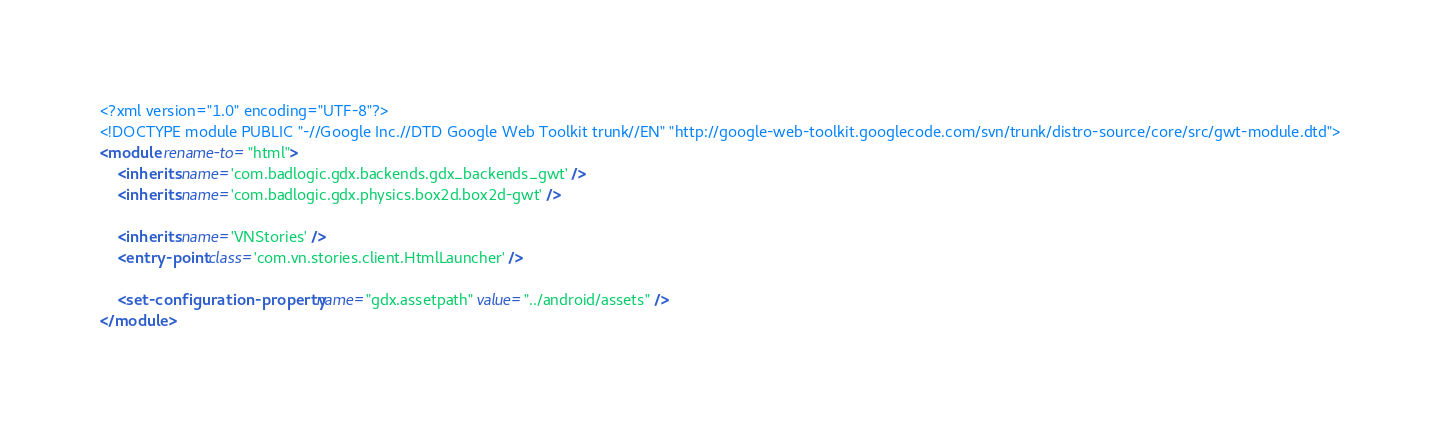Convert code to text. <code><loc_0><loc_0><loc_500><loc_500><_XML_><?xml version="1.0" encoding="UTF-8"?>
<!DOCTYPE module PUBLIC "-//Google Inc.//DTD Google Web Toolkit trunk//EN" "http://google-web-toolkit.googlecode.com/svn/trunk/distro-source/core/src/gwt-module.dtd">
<module rename-to="html">
	<inherits name='com.badlogic.gdx.backends.gdx_backends_gwt' />
	<inherits name='com.badlogic.gdx.physics.box2d.box2d-gwt' />

	<inherits name='VNStories' />
	<entry-point class='com.vn.stories.client.HtmlLauncher' />
	
	<set-configuration-property name="gdx.assetpath" value="../android/assets" />
</module>
</code> 